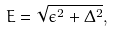Convert formula to latex. <formula><loc_0><loc_0><loc_500><loc_500>E = \sqrt { \epsilon ^ { 2 } + \Delta ^ { 2 } } ,</formula> 